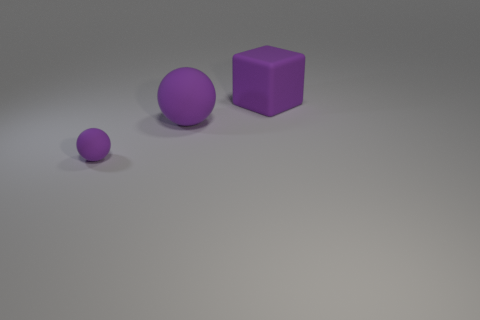Considering the arrangement, could there be any specific pattern or purpose to how the objects are placed? The objects do not seem to follow a discernible pattern that suggests a functional purpose. Rather, their placement and uniform color give them an aesthetic appeal, potentially arranged for artistic or illustrative purposes. 